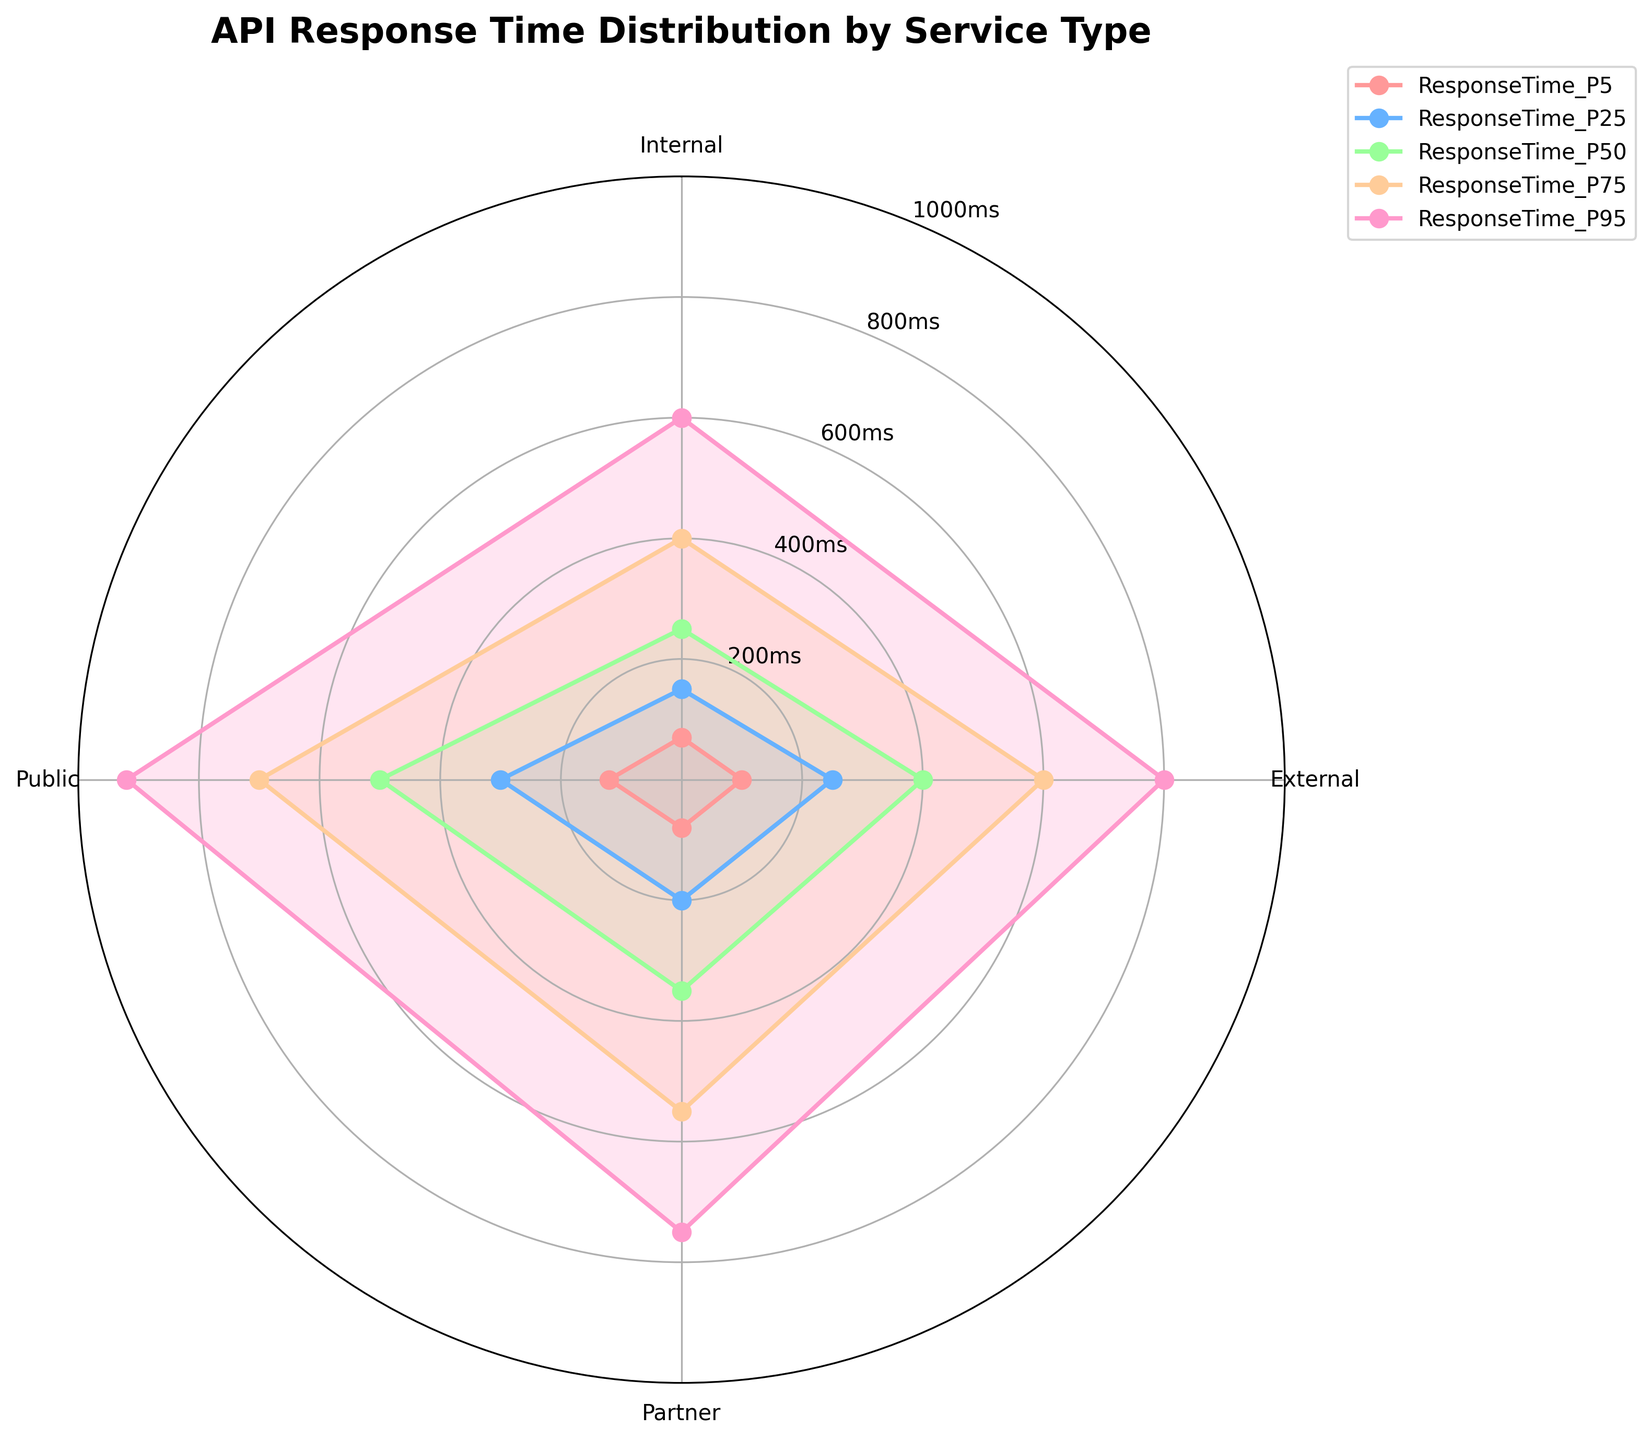what is the title of the chart? The chart title is positioned above the radar chart, in bold with a larger font size.
Answer: API Response Time Distribution by Service Type how many service types are displayed in the chart? The radar chart has labels for each of the service types around the perimeter of the chart. Counting these labels reveals there are four.
Answer: 4 which service type has the highest 95th percentile response time? Locate the line corresponding to the 95th percentile (usually noted in the legend) and identify the service type at the highest point. Public service has the peak closest to 920ms for the 95th percentile.
Answer: Public what is the median response time for internal services? For the median response time, we look at the 50th percentile data point for Internal services. This value is found in the radial direction specific to Internal services on the radar chart.
Answer: 250ms which service type shows the lowest 5th percentile response time? Locate the line corresponding to the 5th percentile and identify the service type with the lowest point. This is where Internal services intersect at 70ms.
Answer: Internal how does the 75th percentile response time for External and Partner services compare? Find and compare where the 75th percentile data points sit for both External and Partner services on the radial scale. External is at 600ms, while Partner is at 550ms, making External higher.
Answer: External is higher what is the range of response times for Public services between the 5th and 95th percentiles? Calculate the range by subtracting the 5th percentile value (120ms) from the 95th percentile value (920ms).
Answer: 800ms which service type has the most consistent response times across all percentiles? Consistent response times would imply minimal spreading across the radial lines. By visually examining the radar chart, the Internal service shows closer lines across percentiles.
Answer: Internal what pattern is seen in the 25th percentile response times for all service types? Observe the radial line representing the 25th percentile and note the response times. Internal (150ms), External (250ms), Partner (200ms), and Public (300ms) show an increasing pattern.
Answer: Increasing how do Internal and External services compare in terms of their median response time? The angles corresponding to the 50th percentile for Internal (250ms) and External (400ms) show that the median response time is higher for External services compared to Internal services.
Answer: External is higher 